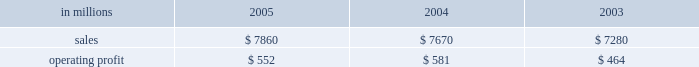Were more than offset by higher raw material and energy costs ( $ 312 million ) , increased market related downtime ( $ 187 million ) and other items ( $ 30 million ) .
Com- pared with 2003 , higher 2005 earnings in the brazilian papers , u.s .
Coated papers and u.s .
Market pulp busi- nesses were offset by lower earnings in the u.s .
Un- coated papers and the european papers businesses .
The printing papers segment took 995000 tons of downtime in 2005 , including 540000 tons of lack-of-order down- time to align production with customer demand .
This compared with 525000 tons of downtime in 2004 , of which 65000 tons related to lack-of-orders .
Printing papers in millions 2005 2004 2003 .
Uncoated papers sales totaled $ 4.8 billion in 2005 compared with $ 5.0 billion in 2004 and 2003 .
Sales price realizations in the united states averaged 4.4% ( 4.4 % ) higher in 2005 than in 2004 , and 4.6% ( 4.6 % ) higher than 2003 .
Favorable pricing momentum which began in 2004 carried over into the beginning of 2005 .
Demand , however , began to weaken across all grades as the year progressed , resulting in lower price realizations in the second and third quarters .
However , prices stabilized as the year ended .
Total shipments for the year were 7.2% ( 7.2 % ) lower than in 2004 and 4.2% ( 4.2 % ) lower than in 2003 .
To continue matching our productive capacity with customer demand , the business announced the perma- nent closure of three uncoated freesheet machines and took significant lack-of-order downtime during the period .
Demand showed some improvement toward the end of the year , bolstered by the introduction our new line of vision innovation paper products ( vip technologiestm ) , with improved brightness and white- ness .
Mill operations were favorable compared to last year , and the rebuild of the no .
1 machine at the east- over , south carolina mill was completed as planned in the fourth quarter .
However , the favorable impacts of improved mill operations and lower overhead costs were more than offset by record high input costs for energy and wood and higher transportation costs compared to 2004 .
The earnings decline in 2005 compared with 2003 was principally due to lower shipments , higher down- time and increased costs for wood , energy and trans- portation , partially offset by lower overhead costs and favorable mill operations .
Average sales price realizations for our european operations remained relatively stable during 2005 , but averaged 1% ( 1 % ) lower than in 2004 , and 6% ( 6 % ) below 2003 levels .
Sales volumes rose slightly , up 1% ( 1 % ) in 2005 com- pared with 2004 and 5% ( 5 % ) compared to 2003 .
Earnings were lower than in 2004 , reflecting higher wood and energy costs and a compression of margins due to un- favorable foreign currency exchange movements .
Earn- ings were also adversely affected by downtime related to the rebuild of three paper machines during the year .
Coated papers sales in the united states were $ 1.6 bil- lion in 2005 , compared with $ 1.4 billion in 2004 and $ 1.3 billion in 2003 .
The business reported an operating profit in 2005 versus a small operating loss in 2004 .
The earnings improvement was driven by higher average sales prices and improved mill operations .
Price realiza- tions in 2005 averaged 13% ( 13 % ) higher than 2004 .
Higher input costs for raw materials and energy partially offset the benefits from improved prices and operations .
Sales volumes were about 1% ( 1 % ) lower in 2005 versus 2004 .
Market pulp sales from our u.s .
And european facilities totaled $ 757 million in 2005 compared with $ 661 mil- lion and $ 571 million in 2004 and 2003 , respectively .
Operating profits in 2005 were up 86% ( 86 % ) from 2004 .
An operating loss had been reported in 2003 .
Higher aver- age prices and sales volumes , lower overhead costs and improved mill operations in 2005 more than offset in- creases in raw material , energy and chemical costs .
U.s .
Softwood and hardwood pulp prices improved through the 2005 first and second quarters , then declined during the third quarter , but recovered somewhat toward year end .
Softwood pulp prices ended the year about 2% ( 2 % ) lower than 2004 , but were 15% ( 15 % ) higher than 2003 , while hardwood pulp prices ended the year about 15% ( 15 % ) higher than 2004 and 10% ( 10 % ) higher than 2003 .
U.s .
Pulp sales volumes were 12% ( 12 % ) higher than in 2004 and 19% ( 19 % ) higher than in 2003 , reflecting increased global demand .
Euro- pean pulp volumes increased 15% ( 15 % ) and 2% ( 2 % ) compared with 2004 and 2003 , respectively , while average sales prices increased 4% ( 4 % ) and 11% ( 11 % ) compared with 2004 and 2003 , respectively .
Brazilian paper sales were $ 684 million in 2005 com- pared with $ 592 million in 2004 and $ 540 million in 2003 .
Sales volumes for uncoated freesheet paper , coated paper and wood chips were down from 2004 , but average price realizations improved for exported un- coated freesheet and coated groundwood paper grades .
Favorable currency translation , as yearly average real exchange rates versus the u.s .
Dollar were 17% ( 17 % ) higher in 2005 than in 2004 , positively impacted reported sales in u.s .
Dollars .
Average sales prices for domestic un- coated paper declined 4% ( 4 % ) in local currency versus 2004 , while domestic coated paper prices were down 3% ( 3 % ) .
Operating profits in 2005 were down 9% ( 9 % ) from 2004 , but were up 2% ( 2 % ) from 2003 .
Earnings in 2005 were neg- atively impacted by a weaker product and geographic sales mix for both uncoated and coated papers , reflecting increased competition and softer demand , particularly in the printing , commercial and editorial market segments. .
What percentage of printing paper sales is attributable to uncoated papers sales in 2005? 
Computations: ((4.8 * 1000) / 7860)
Answer: 0.61069. Were more than offset by higher raw material and energy costs ( $ 312 million ) , increased market related downtime ( $ 187 million ) and other items ( $ 30 million ) .
Com- pared with 2003 , higher 2005 earnings in the brazilian papers , u.s .
Coated papers and u.s .
Market pulp busi- nesses were offset by lower earnings in the u.s .
Un- coated papers and the european papers businesses .
The printing papers segment took 995000 tons of downtime in 2005 , including 540000 tons of lack-of-order down- time to align production with customer demand .
This compared with 525000 tons of downtime in 2004 , of which 65000 tons related to lack-of-orders .
Printing papers in millions 2005 2004 2003 .
Uncoated papers sales totaled $ 4.8 billion in 2005 compared with $ 5.0 billion in 2004 and 2003 .
Sales price realizations in the united states averaged 4.4% ( 4.4 % ) higher in 2005 than in 2004 , and 4.6% ( 4.6 % ) higher than 2003 .
Favorable pricing momentum which began in 2004 carried over into the beginning of 2005 .
Demand , however , began to weaken across all grades as the year progressed , resulting in lower price realizations in the second and third quarters .
However , prices stabilized as the year ended .
Total shipments for the year were 7.2% ( 7.2 % ) lower than in 2004 and 4.2% ( 4.2 % ) lower than in 2003 .
To continue matching our productive capacity with customer demand , the business announced the perma- nent closure of three uncoated freesheet machines and took significant lack-of-order downtime during the period .
Demand showed some improvement toward the end of the year , bolstered by the introduction our new line of vision innovation paper products ( vip technologiestm ) , with improved brightness and white- ness .
Mill operations were favorable compared to last year , and the rebuild of the no .
1 machine at the east- over , south carolina mill was completed as planned in the fourth quarter .
However , the favorable impacts of improved mill operations and lower overhead costs were more than offset by record high input costs for energy and wood and higher transportation costs compared to 2004 .
The earnings decline in 2005 compared with 2003 was principally due to lower shipments , higher down- time and increased costs for wood , energy and trans- portation , partially offset by lower overhead costs and favorable mill operations .
Average sales price realizations for our european operations remained relatively stable during 2005 , but averaged 1% ( 1 % ) lower than in 2004 , and 6% ( 6 % ) below 2003 levels .
Sales volumes rose slightly , up 1% ( 1 % ) in 2005 com- pared with 2004 and 5% ( 5 % ) compared to 2003 .
Earnings were lower than in 2004 , reflecting higher wood and energy costs and a compression of margins due to un- favorable foreign currency exchange movements .
Earn- ings were also adversely affected by downtime related to the rebuild of three paper machines during the year .
Coated papers sales in the united states were $ 1.6 bil- lion in 2005 , compared with $ 1.4 billion in 2004 and $ 1.3 billion in 2003 .
The business reported an operating profit in 2005 versus a small operating loss in 2004 .
The earnings improvement was driven by higher average sales prices and improved mill operations .
Price realiza- tions in 2005 averaged 13% ( 13 % ) higher than 2004 .
Higher input costs for raw materials and energy partially offset the benefits from improved prices and operations .
Sales volumes were about 1% ( 1 % ) lower in 2005 versus 2004 .
Market pulp sales from our u.s .
And european facilities totaled $ 757 million in 2005 compared with $ 661 mil- lion and $ 571 million in 2004 and 2003 , respectively .
Operating profits in 2005 were up 86% ( 86 % ) from 2004 .
An operating loss had been reported in 2003 .
Higher aver- age prices and sales volumes , lower overhead costs and improved mill operations in 2005 more than offset in- creases in raw material , energy and chemical costs .
U.s .
Softwood and hardwood pulp prices improved through the 2005 first and second quarters , then declined during the third quarter , but recovered somewhat toward year end .
Softwood pulp prices ended the year about 2% ( 2 % ) lower than 2004 , but were 15% ( 15 % ) higher than 2003 , while hardwood pulp prices ended the year about 15% ( 15 % ) higher than 2004 and 10% ( 10 % ) higher than 2003 .
U.s .
Pulp sales volumes were 12% ( 12 % ) higher than in 2004 and 19% ( 19 % ) higher than in 2003 , reflecting increased global demand .
Euro- pean pulp volumes increased 15% ( 15 % ) and 2% ( 2 % ) compared with 2004 and 2003 , respectively , while average sales prices increased 4% ( 4 % ) and 11% ( 11 % ) compared with 2004 and 2003 , respectively .
Brazilian paper sales were $ 684 million in 2005 com- pared with $ 592 million in 2004 and $ 540 million in 2003 .
Sales volumes for uncoated freesheet paper , coated paper and wood chips were down from 2004 , but average price realizations improved for exported un- coated freesheet and coated groundwood paper grades .
Favorable currency translation , as yearly average real exchange rates versus the u.s .
Dollar were 17% ( 17 % ) higher in 2005 than in 2004 , positively impacted reported sales in u.s .
Dollars .
Average sales prices for domestic un- coated paper declined 4% ( 4 % ) in local currency versus 2004 , while domestic coated paper prices were down 3% ( 3 % ) .
Operating profits in 2005 were down 9% ( 9 % ) from 2004 , but were up 2% ( 2 % ) from 2003 .
Earnings in 2005 were neg- atively impacted by a weaker product and geographic sales mix for both uncoated and coated papers , reflecting increased competition and softer demand , particularly in the printing , commercial and editorial market segments. .
What percentage of printing paper sales is attributable to uncoated papers sales in 2004? 
Computations: ((5 * 1000) / 7670)
Answer: 0.65189. 